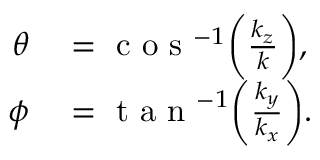<formula> <loc_0><loc_0><loc_500><loc_500>\begin{array} { r l } { \theta } & = c o s ^ { - 1 } \left ( \frac { k _ { z } } { k } \right ) , } \\ { \phi } & = t a n ^ { - 1 } \left ( \frac { k _ { y } } { k _ { x } } \right ) . } \end{array}</formula> 